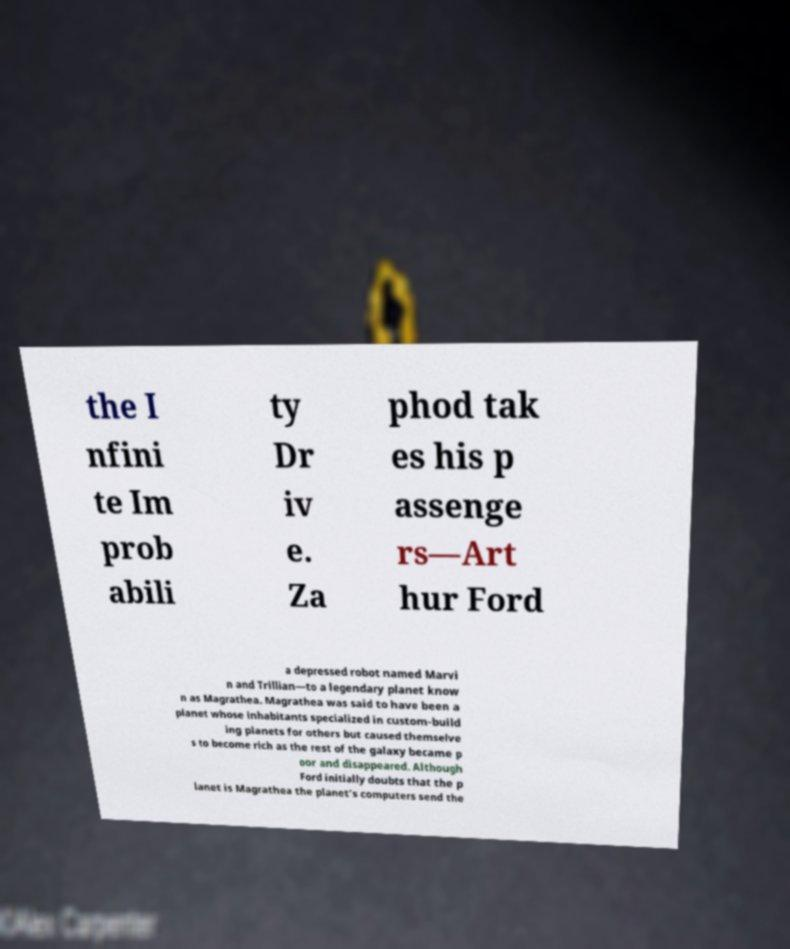For documentation purposes, I need the text within this image transcribed. Could you provide that? the I nfini te Im prob abili ty Dr iv e. Za phod tak es his p assenge rs—Art hur Ford a depressed robot named Marvi n and Trillian—to a legendary planet know n as Magrathea. Magrathea was said to have been a planet whose inhabitants specialized in custom-build ing planets for others but caused themselve s to become rich as the rest of the galaxy became p oor and disappeared. Although Ford initially doubts that the p lanet is Magrathea the planet's computers send the 